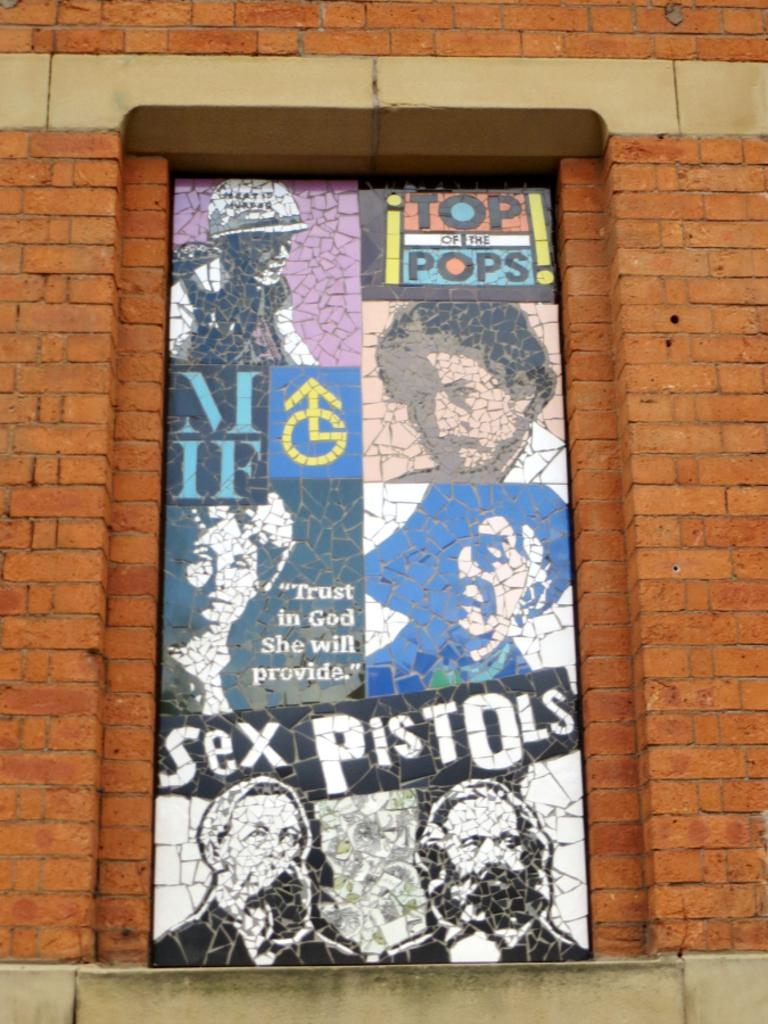<image>
Summarize the visual content of the image. Sex Pistols are shown on this clever art display. 